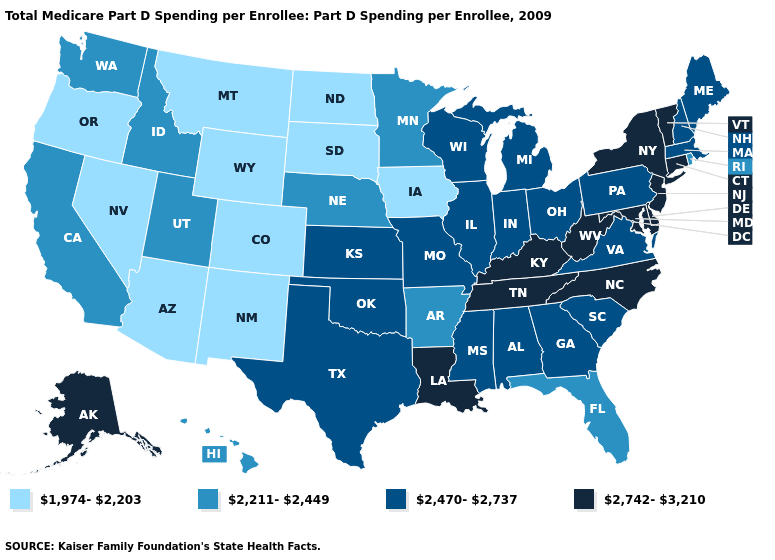What is the value of Tennessee?
Concise answer only. 2,742-3,210. What is the value of Wisconsin?
Answer briefly. 2,470-2,737. Which states have the highest value in the USA?
Answer briefly. Alaska, Connecticut, Delaware, Kentucky, Louisiana, Maryland, New Jersey, New York, North Carolina, Tennessee, Vermont, West Virginia. Which states hav the highest value in the South?
Short answer required. Delaware, Kentucky, Louisiana, Maryland, North Carolina, Tennessee, West Virginia. Does Illinois have the highest value in the MidWest?
Answer briefly. Yes. What is the value of Iowa?
Write a very short answer. 1,974-2,203. What is the highest value in the South ?
Quick response, please. 2,742-3,210. Does the first symbol in the legend represent the smallest category?
Be succinct. Yes. Name the states that have a value in the range 2,742-3,210?
Be succinct. Alaska, Connecticut, Delaware, Kentucky, Louisiana, Maryland, New Jersey, New York, North Carolina, Tennessee, Vermont, West Virginia. Which states have the lowest value in the South?
Concise answer only. Arkansas, Florida. Does the map have missing data?
Concise answer only. No. What is the highest value in the MidWest ?
Answer briefly. 2,470-2,737. Among the states that border Nebraska , does Kansas have the highest value?
Short answer required. Yes. Does North Dakota have the highest value in the MidWest?
Quick response, please. No. What is the lowest value in the USA?
Be succinct. 1,974-2,203. 